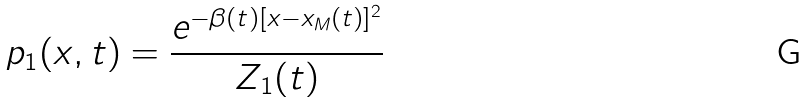Convert formula to latex. <formula><loc_0><loc_0><loc_500><loc_500>p _ { 1 } ( x , t ) = \frac { e ^ { - \beta ( t ) [ x - x _ { M } ( t ) ] ^ { 2 } } } { Z _ { 1 } ( t ) }</formula> 